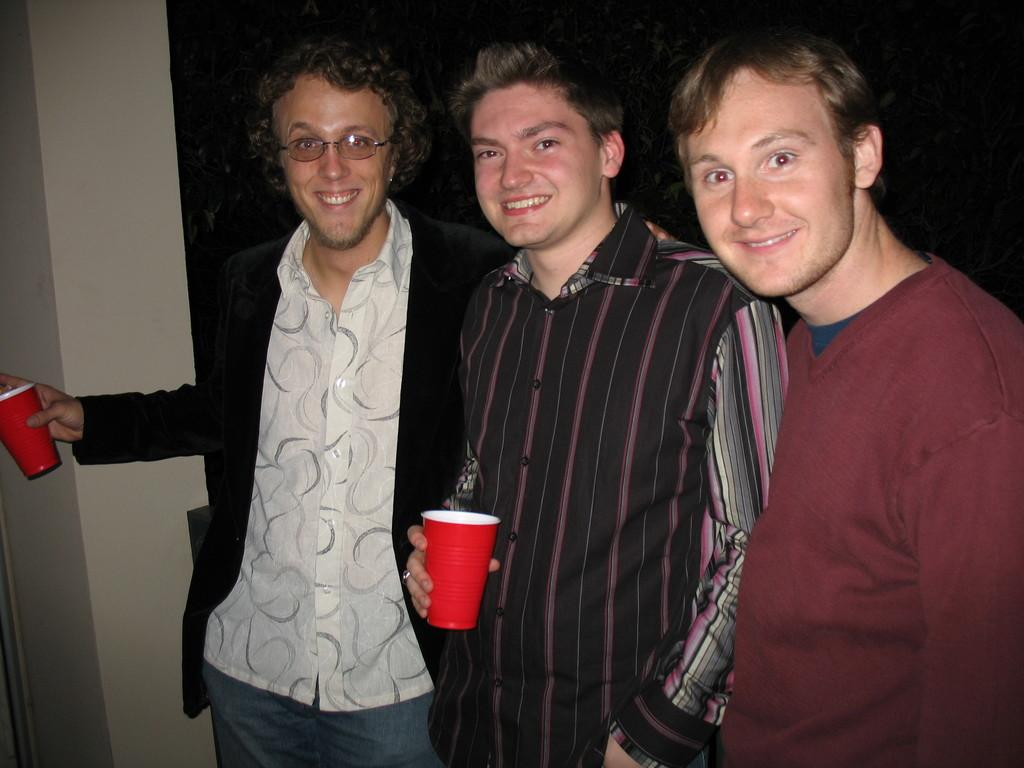How many people are in the image? There are three people in the image. What are the people doing in the image? The people are standing and posing for the picture. What are the two people holding in their hands? The two people are holding glasses in their hands. What can be observed about the background of the image? The background of the image is dark. How many cent patches can be seen on the people's clothing in the image? There are no cent patches visible on the people's clothing in the image. Are there any bears present in the image? There are no bears present in the image. 